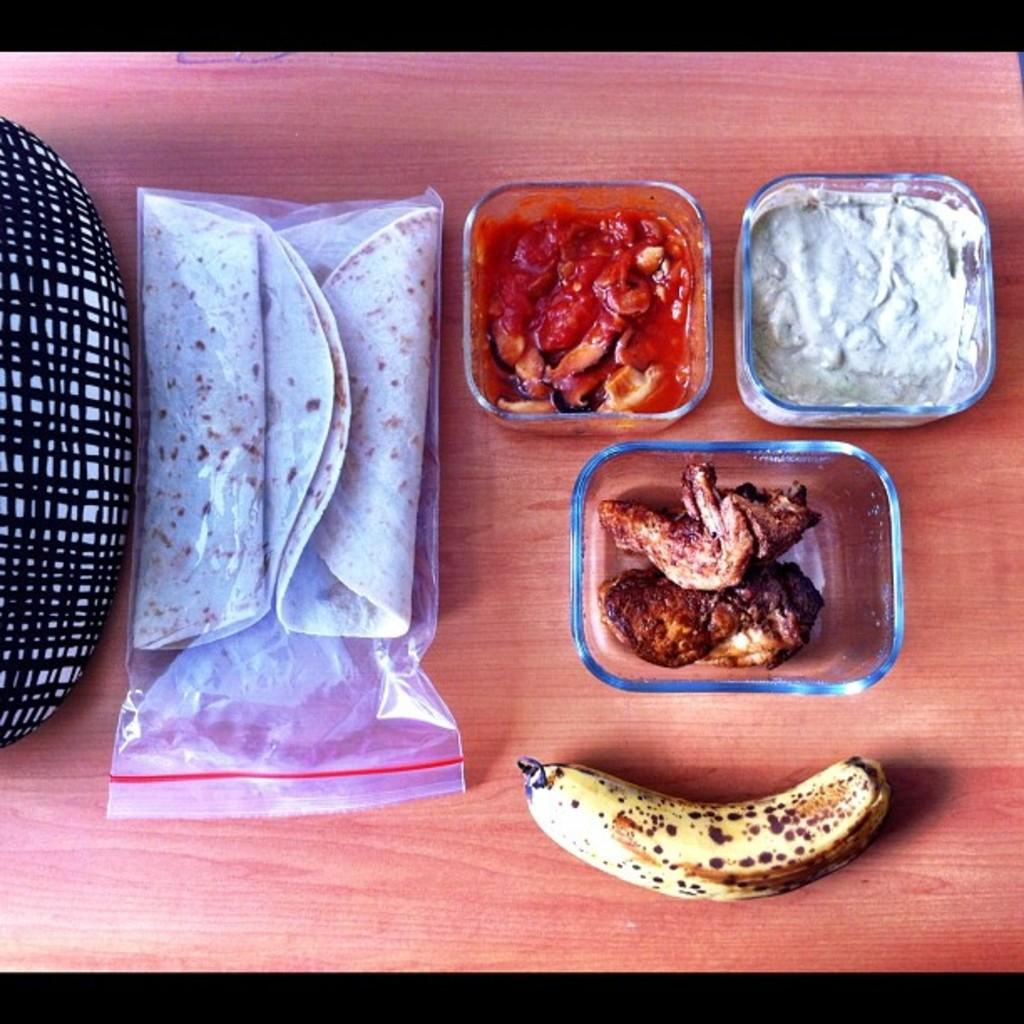What is the main piece of furniture in the image? There is a table in the image. What is covering the food on the table? The table contains a zip lock cover. What type of fruit is on the table? There is a banana on the table. What type of food is in the bowls on the table? There are bowls with food on the table. Can you describe the object on the left side of the image? Unfortunately, the provided facts do not give any information about the object on the left side of the image. What is the taste of the dinosaurs in the image? There are no dinosaurs present in the image, so it is not possible to determine their taste. 